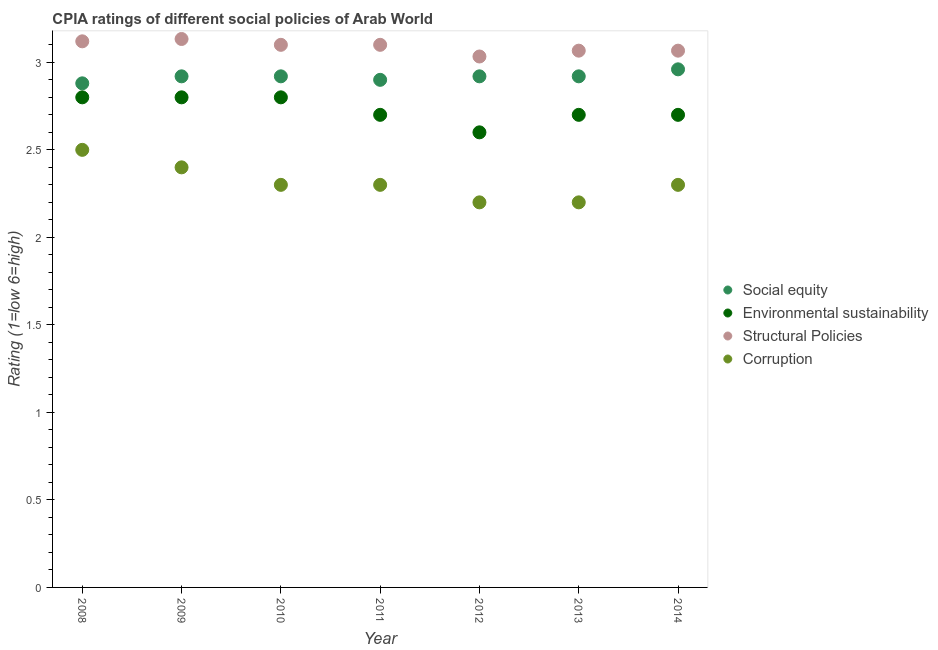Is the number of dotlines equal to the number of legend labels?
Provide a short and direct response. Yes. What is the cpia rating of social equity in 2008?
Offer a terse response. 2.88. Across all years, what is the maximum cpia rating of structural policies?
Ensure brevity in your answer.  3.13. Across all years, what is the minimum cpia rating of social equity?
Keep it short and to the point. 2.88. In which year was the cpia rating of structural policies maximum?
Ensure brevity in your answer.  2009. In which year was the cpia rating of corruption minimum?
Provide a succinct answer. 2012. What is the total cpia rating of social equity in the graph?
Ensure brevity in your answer.  20.42. What is the difference between the cpia rating of environmental sustainability in 2012 and that in 2013?
Keep it short and to the point. -0.1. What is the difference between the cpia rating of corruption in 2008 and the cpia rating of social equity in 2009?
Ensure brevity in your answer.  -0.42. What is the average cpia rating of environmental sustainability per year?
Make the answer very short. 2.73. In the year 2013, what is the difference between the cpia rating of corruption and cpia rating of structural policies?
Make the answer very short. -0.87. What is the ratio of the cpia rating of environmental sustainability in 2009 to that in 2012?
Provide a short and direct response. 1.08. What is the difference between the highest and the second highest cpia rating of social equity?
Your answer should be compact. 0.04. What is the difference between the highest and the lowest cpia rating of structural policies?
Make the answer very short. 0.1. Is the sum of the cpia rating of structural policies in 2010 and 2013 greater than the maximum cpia rating of environmental sustainability across all years?
Offer a terse response. Yes. Is it the case that in every year, the sum of the cpia rating of environmental sustainability and cpia rating of social equity is greater than the sum of cpia rating of structural policies and cpia rating of corruption?
Keep it short and to the point. Yes. Is it the case that in every year, the sum of the cpia rating of social equity and cpia rating of environmental sustainability is greater than the cpia rating of structural policies?
Give a very brief answer. Yes. Does the cpia rating of corruption monotonically increase over the years?
Offer a terse response. No. How many dotlines are there?
Provide a succinct answer. 4. How many years are there in the graph?
Provide a succinct answer. 7. What is the difference between two consecutive major ticks on the Y-axis?
Offer a terse response. 0.5. Does the graph contain any zero values?
Provide a succinct answer. No. How are the legend labels stacked?
Ensure brevity in your answer.  Vertical. What is the title of the graph?
Offer a very short reply. CPIA ratings of different social policies of Arab World. What is the Rating (1=low 6=high) of Social equity in 2008?
Offer a very short reply. 2.88. What is the Rating (1=low 6=high) in Environmental sustainability in 2008?
Your response must be concise. 2.8. What is the Rating (1=low 6=high) of Structural Policies in 2008?
Provide a short and direct response. 3.12. What is the Rating (1=low 6=high) of Social equity in 2009?
Give a very brief answer. 2.92. What is the Rating (1=low 6=high) in Structural Policies in 2009?
Provide a short and direct response. 3.13. What is the Rating (1=low 6=high) of Corruption in 2009?
Keep it short and to the point. 2.4. What is the Rating (1=low 6=high) in Social equity in 2010?
Provide a short and direct response. 2.92. What is the Rating (1=low 6=high) of Structural Policies in 2010?
Ensure brevity in your answer.  3.1. What is the Rating (1=low 6=high) in Social equity in 2011?
Keep it short and to the point. 2.9. What is the Rating (1=low 6=high) of Environmental sustainability in 2011?
Offer a terse response. 2.7. What is the Rating (1=low 6=high) of Structural Policies in 2011?
Make the answer very short. 3.1. What is the Rating (1=low 6=high) of Social equity in 2012?
Make the answer very short. 2.92. What is the Rating (1=low 6=high) of Structural Policies in 2012?
Offer a terse response. 3.03. What is the Rating (1=low 6=high) of Social equity in 2013?
Ensure brevity in your answer.  2.92. What is the Rating (1=low 6=high) in Structural Policies in 2013?
Make the answer very short. 3.07. What is the Rating (1=low 6=high) of Corruption in 2013?
Give a very brief answer. 2.2. What is the Rating (1=low 6=high) in Social equity in 2014?
Make the answer very short. 2.96. What is the Rating (1=low 6=high) in Environmental sustainability in 2014?
Provide a succinct answer. 2.7. What is the Rating (1=low 6=high) of Structural Policies in 2014?
Keep it short and to the point. 3.07. What is the Rating (1=low 6=high) of Corruption in 2014?
Make the answer very short. 2.3. Across all years, what is the maximum Rating (1=low 6=high) of Social equity?
Your answer should be compact. 2.96. Across all years, what is the maximum Rating (1=low 6=high) of Environmental sustainability?
Give a very brief answer. 2.8. Across all years, what is the maximum Rating (1=low 6=high) in Structural Policies?
Make the answer very short. 3.13. Across all years, what is the maximum Rating (1=low 6=high) in Corruption?
Your answer should be compact. 2.5. Across all years, what is the minimum Rating (1=low 6=high) in Social equity?
Provide a short and direct response. 2.88. Across all years, what is the minimum Rating (1=low 6=high) in Structural Policies?
Provide a succinct answer. 3.03. What is the total Rating (1=low 6=high) in Social equity in the graph?
Offer a very short reply. 20.42. What is the total Rating (1=low 6=high) of Environmental sustainability in the graph?
Give a very brief answer. 19.1. What is the total Rating (1=low 6=high) of Structural Policies in the graph?
Offer a terse response. 21.62. What is the difference between the Rating (1=low 6=high) of Social equity in 2008 and that in 2009?
Give a very brief answer. -0.04. What is the difference between the Rating (1=low 6=high) of Environmental sustainability in 2008 and that in 2009?
Offer a very short reply. 0. What is the difference between the Rating (1=low 6=high) in Structural Policies in 2008 and that in 2009?
Your answer should be very brief. -0.01. What is the difference between the Rating (1=low 6=high) of Social equity in 2008 and that in 2010?
Your response must be concise. -0.04. What is the difference between the Rating (1=low 6=high) of Structural Policies in 2008 and that in 2010?
Offer a terse response. 0.02. What is the difference between the Rating (1=low 6=high) of Corruption in 2008 and that in 2010?
Provide a succinct answer. 0.2. What is the difference between the Rating (1=low 6=high) in Social equity in 2008 and that in 2011?
Provide a short and direct response. -0.02. What is the difference between the Rating (1=low 6=high) in Environmental sustainability in 2008 and that in 2011?
Give a very brief answer. 0.1. What is the difference between the Rating (1=low 6=high) in Social equity in 2008 and that in 2012?
Offer a terse response. -0.04. What is the difference between the Rating (1=low 6=high) in Environmental sustainability in 2008 and that in 2012?
Your response must be concise. 0.2. What is the difference between the Rating (1=low 6=high) in Structural Policies in 2008 and that in 2012?
Ensure brevity in your answer.  0.09. What is the difference between the Rating (1=low 6=high) of Corruption in 2008 and that in 2012?
Offer a terse response. 0.3. What is the difference between the Rating (1=low 6=high) of Social equity in 2008 and that in 2013?
Ensure brevity in your answer.  -0.04. What is the difference between the Rating (1=low 6=high) in Structural Policies in 2008 and that in 2013?
Ensure brevity in your answer.  0.05. What is the difference between the Rating (1=low 6=high) in Social equity in 2008 and that in 2014?
Keep it short and to the point. -0.08. What is the difference between the Rating (1=low 6=high) in Structural Policies in 2008 and that in 2014?
Your answer should be compact. 0.05. What is the difference between the Rating (1=low 6=high) of Corruption in 2008 and that in 2014?
Your answer should be very brief. 0.2. What is the difference between the Rating (1=low 6=high) in Environmental sustainability in 2009 and that in 2010?
Provide a short and direct response. 0. What is the difference between the Rating (1=low 6=high) in Social equity in 2009 and that in 2011?
Your answer should be compact. 0.02. What is the difference between the Rating (1=low 6=high) in Environmental sustainability in 2009 and that in 2011?
Your answer should be very brief. 0.1. What is the difference between the Rating (1=low 6=high) of Corruption in 2009 and that in 2011?
Your response must be concise. 0.1. What is the difference between the Rating (1=low 6=high) in Environmental sustainability in 2009 and that in 2012?
Give a very brief answer. 0.2. What is the difference between the Rating (1=low 6=high) in Structural Policies in 2009 and that in 2012?
Offer a terse response. 0.1. What is the difference between the Rating (1=low 6=high) of Corruption in 2009 and that in 2012?
Offer a very short reply. 0.2. What is the difference between the Rating (1=low 6=high) of Environmental sustainability in 2009 and that in 2013?
Your answer should be very brief. 0.1. What is the difference between the Rating (1=low 6=high) in Structural Policies in 2009 and that in 2013?
Your answer should be compact. 0.07. What is the difference between the Rating (1=low 6=high) in Corruption in 2009 and that in 2013?
Your answer should be compact. 0.2. What is the difference between the Rating (1=low 6=high) of Social equity in 2009 and that in 2014?
Offer a very short reply. -0.04. What is the difference between the Rating (1=low 6=high) in Structural Policies in 2009 and that in 2014?
Make the answer very short. 0.07. What is the difference between the Rating (1=low 6=high) of Corruption in 2009 and that in 2014?
Provide a succinct answer. 0.1. What is the difference between the Rating (1=low 6=high) of Social equity in 2010 and that in 2011?
Your response must be concise. 0.02. What is the difference between the Rating (1=low 6=high) of Social equity in 2010 and that in 2012?
Offer a terse response. 0. What is the difference between the Rating (1=low 6=high) in Structural Policies in 2010 and that in 2012?
Offer a terse response. 0.07. What is the difference between the Rating (1=low 6=high) of Corruption in 2010 and that in 2012?
Offer a very short reply. 0.1. What is the difference between the Rating (1=low 6=high) of Social equity in 2010 and that in 2013?
Ensure brevity in your answer.  0. What is the difference between the Rating (1=low 6=high) in Structural Policies in 2010 and that in 2013?
Keep it short and to the point. 0.03. What is the difference between the Rating (1=low 6=high) in Corruption in 2010 and that in 2013?
Offer a terse response. 0.1. What is the difference between the Rating (1=low 6=high) in Social equity in 2010 and that in 2014?
Offer a terse response. -0.04. What is the difference between the Rating (1=low 6=high) of Social equity in 2011 and that in 2012?
Provide a succinct answer. -0.02. What is the difference between the Rating (1=low 6=high) of Environmental sustainability in 2011 and that in 2012?
Keep it short and to the point. 0.1. What is the difference between the Rating (1=low 6=high) of Structural Policies in 2011 and that in 2012?
Offer a very short reply. 0.07. What is the difference between the Rating (1=low 6=high) in Social equity in 2011 and that in 2013?
Your answer should be compact. -0.02. What is the difference between the Rating (1=low 6=high) of Structural Policies in 2011 and that in 2013?
Your answer should be compact. 0.03. What is the difference between the Rating (1=low 6=high) of Corruption in 2011 and that in 2013?
Your answer should be very brief. 0.1. What is the difference between the Rating (1=low 6=high) of Social equity in 2011 and that in 2014?
Make the answer very short. -0.06. What is the difference between the Rating (1=low 6=high) in Social equity in 2012 and that in 2013?
Your answer should be very brief. 0. What is the difference between the Rating (1=low 6=high) in Environmental sustainability in 2012 and that in 2013?
Ensure brevity in your answer.  -0.1. What is the difference between the Rating (1=low 6=high) of Structural Policies in 2012 and that in 2013?
Give a very brief answer. -0.03. What is the difference between the Rating (1=low 6=high) of Social equity in 2012 and that in 2014?
Keep it short and to the point. -0.04. What is the difference between the Rating (1=low 6=high) of Structural Policies in 2012 and that in 2014?
Your answer should be compact. -0.03. What is the difference between the Rating (1=low 6=high) of Social equity in 2013 and that in 2014?
Your answer should be very brief. -0.04. What is the difference between the Rating (1=low 6=high) of Structural Policies in 2013 and that in 2014?
Provide a succinct answer. -0. What is the difference between the Rating (1=low 6=high) in Corruption in 2013 and that in 2014?
Make the answer very short. -0.1. What is the difference between the Rating (1=low 6=high) of Social equity in 2008 and the Rating (1=low 6=high) of Structural Policies in 2009?
Offer a very short reply. -0.25. What is the difference between the Rating (1=low 6=high) in Social equity in 2008 and the Rating (1=low 6=high) in Corruption in 2009?
Make the answer very short. 0.48. What is the difference between the Rating (1=low 6=high) of Environmental sustainability in 2008 and the Rating (1=low 6=high) of Structural Policies in 2009?
Give a very brief answer. -0.33. What is the difference between the Rating (1=low 6=high) of Environmental sustainability in 2008 and the Rating (1=low 6=high) of Corruption in 2009?
Your answer should be compact. 0.4. What is the difference between the Rating (1=low 6=high) in Structural Policies in 2008 and the Rating (1=low 6=high) in Corruption in 2009?
Offer a very short reply. 0.72. What is the difference between the Rating (1=low 6=high) of Social equity in 2008 and the Rating (1=low 6=high) of Structural Policies in 2010?
Make the answer very short. -0.22. What is the difference between the Rating (1=low 6=high) in Social equity in 2008 and the Rating (1=low 6=high) in Corruption in 2010?
Provide a short and direct response. 0.58. What is the difference between the Rating (1=low 6=high) in Environmental sustainability in 2008 and the Rating (1=low 6=high) in Structural Policies in 2010?
Your response must be concise. -0.3. What is the difference between the Rating (1=low 6=high) in Structural Policies in 2008 and the Rating (1=low 6=high) in Corruption in 2010?
Offer a terse response. 0.82. What is the difference between the Rating (1=low 6=high) of Social equity in 2008 and the Rating (1=low 6=high) of Environmental sustainability in 2011?
Keep it short and to the point. 0.18. What is the difference between the Rating (1=low 6=high) in Social equity in 2008 and the Rating (1=low 6=high) in Structural Policies in 2011?
Your answer should be very brief. -0.22. What is the difference between the Rating (1=low 6=high) of Social equity in 2008 and the Rating (1=low 6=high) of Corruption in 2011?
Your answer should be compact. 0.58. What is the difference between the Rating (1=low 6=high) in Structural Policies in 2008 and the Rating (1=low 6=high) in Corruption in 2011?
Provide a succinct answer. 0.82. What is the difference between the Rating (1=low 6=high) in Social equity in 2008 and the Rating (1=low 6=high) in Environmental sustainability in 2012?
Ensure brevity in your answer.  0.28. What is the difference between the Rating (1=low 6=high) in Social equity in 2008 and the Rating (1=low 6=high) in Structural Policies in 2012?
Your answer should be compact. -0.15. What is the difference between the Rating (1=low 6=high) of Social equity in 2008 and the Rating (1=low 6=high) of Corruption in 2012?
Give a very brief answer. 0.68. What is the difference between the Rating (1=low 6=high) in Environmental sustainability in 2008 and the Rating (1=low 6=high) in Structural Policies in 2012?
Your answer should be compact. -0.23. What is the difference between the Rating (1=low 6=high) of Environmental sustainability in 2008 and the Rating (1=low 6=high) of Corruption in 2012?
Provide a short and direct response. 0.6. What is the difference between the Rating (1=low 6=high) of Social equity in 2008 and the Rating (1=low 6=high) of Environmental sustainability in 2013?
Ensure brevity in your answer.  0.18. What is the difference between the Rating (1=low 6=high) in Social equity in 2008 and the Rating (1=low 6=high) in Structural Policies in 2013?
Offer a terse response. -0.19. What is the difference between the Rating (1=low 6=high) of Social equity in 2008 and the Rating (1=low 6=high) of Corruption in 2013?
Your response must be concise. 0.68. What is the difference between the Rating (1=low 6=high) of Environmental sustainability in 2008 and the Rating (1=low 6=high) of Structural Policies in 2013?
Your response must be concise. -0.27. What is the difference between the Rating (1=low 6=high) of Environmental sustainability in 2008 and the Rating (1=low 6=high) of Corruption in 2013?
Ensure brevity in your answer.  0.6. What is the difference between the Rating (1=low 6=high) in Structural Policies in 2008 and the Rating (1=low 6=high) in Corruption in 2013?
Provide a short and direct response. 0.92. What is the difference between the Rating (1=low 6=high) of Social equity in 2008 and the Rating (1=low 6=high) of Environmental sustainability in 2014?
Your answer should be compact. 0.18. What is the difference between the Rating (1=low 6=high) of Social equity in 2008 and the Rating (1=low 6=high) of Structural Policies in 2014?
Offer a terse response. -0.19. What is the difference between the Rating (1=low 6=high) of Social equity in 2008 and the Rating (1=low 6=high) of Corruption in 2014?
Give a very brief answer. 0.58. What is the difference between the Rating (1=low 6=high) of Environmental sustainability in 2008 and the Rating (1=low 6=high) of Structural Policies in 2014?
Offer a very short reply. -0.27. What is the difference between the Rating (1=low 6=high) of Environmental sustainability in 2008 and the Rating (1=low 6=high) of Corruption in 2014?
Provide a short and direct response. 0.5. What is the difference between the Rating (1=low 6=high) in Structural Policies in 2008 and the Rating (1=low 6=high) in Corruption in 2014?
Your answer should be compact. 0.82. What is the difference between the Rating (1=low 6=high) in Social equity in 2009 and the Rating (1=low 6=high) in Environmental sustainability in 2010?
Offer a very short reply. 0.12. What is the difference between the Rating (1=low 6=high) of Social equity in 2009 and the Rating (1=low 6=high) of Structural Policies in 2010?
Offer a very short reply. -0.18. What is the difference between the Rating (1=low 6=high) of Social equity in 2009 and the Rating (1=low 6=high) of Corruption in 2010?
Provide a succinct answer. 0.62. What is the difference between the Rating (1=low 6=high) of Environmental sustainability in 2009 and the Rating (1=low 6=high) of Structural Policies in 2010?
Provide a succinct answer. -0.3. What is the difference between the Rating (1=low 6=high) of Social equity in 2009 and the Rating (1=low 6=high) of Environmental sustainability in 2011?
Offer a terse response. 0.22. What is the difference between the Rating (1=low 6=high) of Social equity in 2009 and the Rating (1=low 6=high) of Structural Policies in 2011?
Make the answer very short. -0.18. What is the difference between the Rating (1=low 6=high) in Social equity in 2009 and the Rating (1=low 6=high) in Corruption in 2011?
Provide a succinct answer. 0.62. What is the difference between the Rating (1=low 6=high) of Environmental sustainability in 2009 and the Rating (1=low 6=high) of Structural Policies in 2011?
Offer a terse response. -0.3. What is the difference between the Rating (1=low 6=high) in Structural Policies in 2009 and the Rating (1=low 6=high) in Corruption in 2011?
Make the answer very short. 0.83. What is the difference between the Rating (1=low 6=high) in Social equity in 2009 and the Rating (1=low 6=high) in Environmental sustainability in 2012?
Your answer should be very brief. 0.32. What is the difference between the Rating (1=low 6=high) in Social equity in 2009 and the Rating (1=low 6=high) in Structural Policies in 2012?
Your answer should be very brief. -0.11. What is the difference between the Rating (1=low 6=high) of Social equity in 2009 and the Rating (1=low 6=high) of Corruption in 2012?
Offer a terse response. 0.72. What is the difference between the Rating (1=low 6=high) of Environmental sustainability in 2009 and the Rating (1=low 6=high) of Structural Policies in 2012?
Provide a succinct answer. -0.23. What is the difference between the Rating (1=low 6=high) of Social equity in 2009 and the Rating (1=low 6=high) of Environmental sustainability in 2013?
Provide a short and direct response. 0.22. What is the difference between the Rating (1=low 6=high) of Social equity in 2009 and the Rating (1=low 6=high) of Structural Policies in 2013?
Your response must be concise. -0.15. What is the difference between the Rating (1=low 6=high) of Social equity in 2009 and the Rating (1=low 6=high) of Corruption in 2013?
Provide a short and direct response. 0.72. What is the difference between the Rating (1=low 6=high) in Environmental sustainability in 2009 and the Rating (1=low 6=high) in Structural Policies in 2013?
Offer a terse response. -0.27. What is the difference between the Rating (1=low 6=high) of Environmental sustainability in 2009 and the Rating (1=low 6=high) of Corruption in 2013?
Give a very brief answer. 0.6. What is the difference between the Rating (1=low 6=high) of Social equity in 2009 and the Rating (1=low 6=high) of Environmental sustainability in 2014?
Offer a very short reply. 0.22. What is the difference between the Rating (1=low 6=high) of Social equity in 2009 and the Rating (1=low 6=high) of Structural Policies in 2014?
Offer a very short reply. -0.15. What is the difference between the Rating (1=low 6=high) in Social equity in 2009 and the Rating (1=low 6=high) in Corruption in 2014?
Your answer should be compact. 0.62. What is the difference between the Rating (1=low 6=high) of Environmental sustainability in 2009 and the Rating (1=low 6=high) of Structural Policies in 2014?
Provide a short and direct response. -0.27. What is the difference between the Rating (1=low 6=high) in Environmental sustainability in 2009 and the Rating (1=low 6=high) in Corruption in 2014?
Give a very brief answer. 0.5. What is the difference between the Rating (1=low 6=high) in Social equity in 2010 and the Rating (1=low 6=high) in Environmental sustainability in 2011?
Your answer should be very brief. 0.22. What is the difference between the Rating (1=low 6=high) in Social equity in 2010 and the Rating (1=low 6=high) in Structural Policies in 2011?
Keep it short and to the point. -0.18. What is the difference between the Rating (1=low 6=high) in Social equity in 2010 and the Rating (1=low 6=high) in Corruption in 2011?
Ensure brevity in your answer.  0.62. What is the difference between the Rating (1=low 6=high) in Environmental sustainability in 2010 and the Rating (1=low 6=high) in Structural Policies in 2011?
Your response must be concise. -0.3. What is the difference between the Rating (1=low 6=high) of Structural Policies in 2010 and the Rating (1=low 6=high) of Corruption in 2011?
Offer a very short reply. 0.8. What is the difference between the Rating (1=low 6=high) in Social equity in 2010 and the Rating (1=low 6=high) in Environmental sustainability in 2012?
Give a very brief answer. 0.32. What is the difference between the Rating (1=low 6=high) of Social equity in 2010 and the Rating (1=low 6=high) of Structural Policies in 2012?
Ensure brevity in your answer.  -0.11. What is the difference between the Rating (1=low 6=high) in Social equity in 2010 and the Rating (1=low 6=high) in Corruption in 2012?
Keep it short and to the point. 0.72. What is the difference between the Rating (1=low 6=high) in Environmental sustainability in 2010 and the Rating (1=low 6=high) in Structural Policies in 2012?
Give a very brief answer. -0.23. What is the difference between the Rating (1=low 6=high) of Structural Policies in 2010 and the Rating (1=low 6=high) of Corruption in 2012?
Your answer should be compact. 0.9. What is the difference between the Rating (1=low 6=high) in Social equity in 2010 and the Rating (1=low 6=high) in Environmental sustainability in 2013?
Your response must be concise. 0.22. What is the difference between the Rating (1=low 6=high) of Social equity in 2010 and the Rating (1=low 6=high) of Structural Policies in 2013?
Ensure brevity in your answer.  -0.15. What is the difference between the Rating (1=low 6=high) in Social equity in 2010 and the Rating (1=low 6=high) in Corruption in 2013?
Give a very brief answer. 0.72. What is the difference between the Rating (1=low 6=high) of Environmental sustainability in 2010 and the Rating (1=low 6=high) of Structural Policies in 2013?
Your response must be concise. -0.27. What is the difference between the Rating (1=low 6=high) of Social equity in 2010 and the Rating (1=low 6=high) of Environmental sustainability in 2014?
Provide a succinct answer. 0.22. What is the difference between the Rating (1=low 6=high) in Social equity in 2010 and the Rating (1=low 6=high) in Structural Policies in 2014?
Make the answer very short. -0.15. What is the difference between the Rating (1=low 6=high) in Social equity in 2010 and the Rating (1=low 6=high) in Corruption in 2014?
Your response must be concise. 0.62. What is the difference between the Rating (1=low 6=high) of Environmental sustainability in 2010 and the Rating (1=low 6=high) of Structural Policies in 2014?
Offer a very short reply. -0.27. What is the difference between the Rating (1=low 6=high) in Environmental sustainability in 2010 and the Rating (1=low 6=high) in Corruption in 2014?
Your response must be concise. 0.5. What is the difference between the Rating (1=low 6=high) in Social equity in 2011 and the Rating (1=low 6=high) in Structural Policies in 2012?
Your answer should be compact. -0.13. What is the difference between the Rating (1=low 6=high) in Environmental sustainability in 2011 and the Rating (1=low 6=high) in Structural Policies in 2012?
Keep it short and to the point. -0.33. What is the difference between the Rating (1=low 6=high) in Structural Policies in 2011 and the Rating (1=low 6=high) in Corruption in 2012?
Your answer should be compact. 0.9. What is the difference between the Rating (1=low 6=high) of Social equity in 2011 and the Rating (1=low 6=high) of Structural Policies in 2013?
Provide a succinct answer. -0.17. What is the difference between the Rating (1=low 6=high) in Social equity in 2011 and the Rating (1=low 6=high) in Corruption in 2013?
Provide a succinct answer. 0.7. What is the difference between the Rating (1=low 6=high) in Environmental sustainability in 2011 and the Rating (1=low 6=high) in Structural Policies in 2013?
Keep it short and to the point. -0.37. What is the difference between the Rating (1=low 6=high) in Structural Policies in 2011 and the Rating (1=low 6=high) in Corruption in 2013?
Keep it short and to the point. 0.9. What is the difference between the Rating (1=low 6=high) in Social equity in 2011 and the Rating (1=low 6=high) in Structural Policies in 2014?
Ensure brevity in your answer.  -0.17. What is the difference between the Rating (1=low 6=high) in Environmental sustainability in 2011 and the Rating (1=low 6=high) in Structural Policies in 2014?
Your response must be concise. -0.37. What is the difference between the Rating (1=low 6=high) of Environmental sustainability in 2011 and the Rating (1=low 6=high) of Corruption in 2014?
Your response must be concise. 0.4. What is the difference between the Rating (1=low 6=high) in Structural Policies in 2011 and the Rating (1=low 6=high) in Corruption in 2014?
Keep it short and to the point. 0.8. What is the difference between the Rating (1=low 6=high) in Social equity in 2012 and the Rating (1=low 6=high) in Environmental sustainability in 2013?
Make the answer very short. 0.22. What is the difference between the Rating (1=low 6=high) in Social equity in 2012 and the Rating (1=low 6=high) in Structural Policies in 2013?
Give a very brief answer. -0.15. What is the difference between the Rating (1=low 6=high) in Social equity in 2012 and the Rating (1=low 6=high) in Corruption in 2013?
Make the answer very short. 0.72. What is the difference between the Rating (1=low 6=high) in Environmental sustainability in 2012 and the Rating (1=low 6=high) in Structural Policies in 2013?
Your answer should be very brief. -0.47. What is the difference between the Rating (1=low 6=high) in Environmental sustainability in 2012 and the Rating (1=low 6=high) in Corruption in 2013?
Make the answer very short. 0.4. What is the difference between the Rating (1=low 6=high) in Structural Policies in 2012 and the Rating (1=low 6=high) in Corruption in 2013?
Offer a terse response. 0.83. What is the difference between the Rating (1=low 6=high) of Social equity in 2012 and the Rating (1=low 6=high) of Environmental sustainability in 2014?
Provide a short and direct response. 0.22. What is the difference between the Rating (1=low 6=high) of Social equity in 2012 and the Rating (1=low 6=high) of Structural Policies in 2014?
Keep it short and to the point. -0.15. What is the difference between the Rating (1=low 6=high) in Social equity in 2012 and the Rating (1=low 6=high) in Corruption in 2014?
Make the answer very short. 0.62. What is the difference between the Rating (1=low 6=high) of Environmental sustainability in 2012 and the Rating (1=low 6=high) of Structural Policies in 2014?
Provide a short and direct response. -0.47. What is the difference between the Rating (1=low 6=high) of Structural Policies in 2012 and the Rating (1=low 6=high) of Corruption in 2014?
Give a very brief answer. 0.73. What is the difference between the Rating (1=low 6=high) in Social equity in 2013 and the Rating (1=low 6=high) in Environmental sustainability in 2014?
Keep it short and to the point. 0.22. What is the difference between the Rating (1=low 6=high) in Social equity in 2013 and the Rating (1=low 6=high) in Structural Policies in 2014?
Offer a very short reply. -0.15. What is the difference between the Rating (1=low 6=high) of Social equity in 2013 and the Rating (1=low 6=high) of Corruption in 2014?
Give a very brief answer. 0.62. What is the difference between the Rating (1=low 6=high) of Environmental sustainability in 2013 and the Rating (1=low 6=high) of Structural Policies in 2014?
Offer a very short reply. -0.37. What is the difference between the Rating (1=low 6=high) of Environmental sustainability in 2013 and the Rating (1=low 6=high) of Corruption in 2014?
Your answer should be compact. 0.4. What is the difference between the Rating (1=low 6=high) of Structural Policies in 2013 and the Rating (1=low 6=high) of Corruption in 2014?
Offer a terse response. 0.77. What is the average Rating (1=low 6=high) of Social equity per year?
Provide a succinct answer. 2.92. What is the average Rating (1=low 6=high) of Environmental sustainability per year?
Ensure brevity in your answer.  2.73. What is the average Rating (1=low 6=high) of Structural Policies per year?
Make the answer very short. 3.09. What is the average Rating (1=low 6=high) of Corruption per year?
Offer a terse response. 2.31. In the year 2008, what is the difference between the Rating (1=low 6=high) in Social equity and Rating (1=low 6=high) in Structural Policies?
Keep it short and to the point. -0.24. In the year 2008, what is the difference between the Rating (1=low 6=high) in Social equity and Rating (1=low 6=high) in Corruption?
Provide a short and direct response. 0.38. In the year 2008, what is the difference between the Rating (1=low 6=high) of Environmental sustainability and Rating (1=low 6=high) of Structural Policies?
Your answer should be very brief. -0.32. In the year 2008, what is the difference between the Rating (1=low 6=high) of Structural Policies and Rating (1=low 6=high) of Corruption?
Your answer should be compact. 0.62. In the year 2009, what is the difference between the Rating (1=low 6=high) of Social equity and Rating (1=low 6=high) of Environmental sustainability?
Your response must be concise. 0.12. In the year 2009, what is the difference between the Rating (1=low 6=high) in Social equity and Rating (1=low 6=high) in Structural Policies?
Your response must be concise. -0.21. In the year 2009, what is the difference between the Rating (1=low 6=high) in Social equity and Rating (1=low 6=high) in Corruption?
Offer a terse response. 0.52. In the year 2009, what is the difference between the Rating (1=low 6=high) of Structural Policies and Rating (1=low 6=high) of Corruption?
Your answer should be compact. 0.73. In the year 2010, what is the difference between the Rating (1=low 6=high) of Social equity and Rating (1=low 6=high) of Environmental sustainability?
Ensure brevity in your answer.  0.12. In the year 2010, what is the difference between the Rating (1=low 6=high) of Social equity and Rating (1=low 6=high) of Structural Policies?
Provide a succinct answer. -0.18. In the year 2010, what is the difference between the Rating (1=low 6=high) in Social equity and Rating (1=low 6=high) in Corruption?
Offer a terse response. 0.62. In the year 2010, what is the difference between the Rating (1=low 6=high) in Environmental sustainability and Rating (1=low 6=high) in Structural Policies?
Offer a very short reply. -0.3. In the year 2010, what is the difference between the Rating (1=low 6=high) in Structural Policies and Rating (1=low 6=high) in Corruption?
Provide a short and direct response. 0.8. In the year 2011, what is the difference between the Rating (1=low 6=high) of Social equity and Rating (1=low 6=high) of Environmental sustainability?
Ensure brevity in your answer.  0.2. In the year 2011, what is the difference between the Rating (1=low 6=high) of Social equity and Rating (1=low 6=high) of Structural Policies?
Your answer should be very brief. -0.2. In the year 2011, what is the difference between the Rating (1=low 6=high) in Social equity and Rating (1=low 6=high) in Corruption?
Offer a very short reply. 0.6. In the year 2011, what is the difference between the Rating (1=low 6=high) in Environmental sustainability and Rating (1=low 6=high) in Structural Policies?
Keep it short and to the point. -0.4. In the year 2011, what is the difference between the Rating (1=low 6=high) in Environmental sustainability and Rating (1=low 6=high) in Corruption?
Provide a succinct answer. 0.4. In the year 2011, what is the difference between the Rating (1=low 6=high) of Structural Policies and Rating (1=low 6=high) of Corruption?
Make the answer very short. 0.8. In the year 2012, what is the difference between the Rating (1=low 6=high) in Social equity and Rating (1=low 6=high) in Environmental sustainability?
Your answer should be compact. 0.32. In the year 2012, what is the difference between the Rating (1=low 6=high) of Social equity and Rating (1=low 6=high) of Structural Policies?
Offer a very short reply. -0.11. In the year 2012, what is the difference between the Rating (1=low 6=high) in Social equity and Rating (1=low 6=high) in Corruption?
Offer a very short reply. 0.72. In the year 2012, what is the difference between the Rating (1=low 6=high) of Environmental sustainability and Rating (1=low 6=high) of Structural Policies?
Give a very brief answer. -0.43. In the year 2012, what is the difference between the Rating (1=low 6=high) of Environmental sustainability and Rating (1=low 6=high) of Corruption?
Your response must be concise. 0.4. In the year 2013, what is the difference between the Rating (1=low 6=high) of Social equity and Rating (1=low 6=high) of Environmental sustainability?
Provide a succinct answer. 0.22. In the year 2013, what is the difference between the Rating (1=low 6=high) of Social equity and Rating (1=low 6=high) of Structural Policies?
Provide a succinct answer. -0.15. In the year 2013, what is the difference between the Rating (1=low 6=high) in Social equity and Rating (1=low 6=high) in Corruption?
Your answer should be very brief. 0.72. In the year 2013, what is the difference between the Rating (1=low 6=high) of Environmental sustainability and Rating (1=low 6=high) of Structural Policies?
Offer a terse response. -0.37. In the year 2013, what is the difference between the Rating (1=low 6=high) in Environmental sustainability and Rating (1=low 6=high) in Corruption?
Your response must be concise. 0.5. In the year 2013, what is the difference between the Rating (1=low 6=high) in Structural Policies and Rating (1=low 6=high) in Corruption?
Ensure brevity in your answer.  0.87. In the year 2014, what is the difference between the Rating (1=low 6=high) in Social equity and Rating (1=low 6=high) in Environmental sustainability?
Offer a very short reply. 0.26. In the year 2014, what is the difference between the Rating (1=low 6=high) in Social equity and Rating (1=low 6=high) in Structural Policies?
Your response must be concise. -0.11. In the year 2014, what is the difference between the Rating (1=low 6=high) in Social equity and Rating (1=low 6=high) in Corruption?
Offer a terse response. 0.66. In the year 2014, what is the difference between the Rating (1=low 6=high) of Environmental sustainability and Rating (1=low 6=high) of Structural Policies?
Offer a terse response. -0.37. In the year 2014, what is the difference between the Rating (1=low 6=high) in Structural Policies and Rating (1=low 6=high) in Corruption?
Offer a very short reply. 0.77. What is the ratio of the Rating (1=low 6=high) of Social equity in 2008 to that in 2009?
Your answer should be compact. 0.99. What is the ratio of the Rating (1=low 6=high) of Structural Policies in 2008 to that in 2009?
Provide a short and direct response. 1. What is the ratio of the Rating (1=low 6=high) of Corruption in 2008 to that in 2009?
Offer a very short reply. 1.04. What is the ratio of the Rating (1=low 6=high) in Social equity in 2008 to that in 2010?
Give a very brief answer. 0.99. What is the ratio of the Rating (1=low 6=high) of Environmental sustainability in 2008 to that in 2010?
Provide a short and direct response. 1. What is the ratio of the Rating (1=low 6=high) of Corruption in 2008 to that in 2010?
Your answer should be compact. 1.09. What is the ratio of the Rating (1=low 6=high) of Social equity in 2008 to that in 2011?
Your answer should be compact. 0.99. What is the ratio of the Rating (1=low 6=high) of Environmental sustainability in 2008 to that in 2011?
Make the answer very short. 1.04. What is the ratio of the Rating (1=low 6=high) in Corruption in 2008 to that in 2011?
Your response must be concise. 1.09. What is the ratio of the Rating (1=low 6=high) in Social equity in 2008 to that in 2012?
Offer a very short reply. 0.99. What is the ratio of the Rating (1=low 6=high) in Environmental sustainability in 2008 to that in 2012?
Your response must be concise. 1.08. What is the ratio of the Rating (1=low 6=high) in Structural Policies in 2008 to that in 2012?
Provide a short and direct response. 1.03. What is the ratio of the Rating (1=low 6=high) of Corruption in 2008 to that in 2012?
Make the answer very short. 1.14. What is the ratio of the Rating (1=low 6=high) of Social equity in 2008 to that in 2013?
Make the answer very short. 0.99. What is the ratio of the Rating (1=low 6=high) of Structural Policies in 2008 to that in 2013?
Provide a succinct answer. 1.02. What is the ratio of the Rating (1=low 6=high) of Corruption in 2008 to that in 2013?
Provide a short and direct response. 1.14. What is the ratio of the Rating (1=low 6=high) of Social equity in 2008 to that in 2014?
Offer a terse response. 0.97. What is the ratio of the Rating (1=low 6=high) in Structural Policies in 2008 to that in 2014?
Give a very brief answer. 1.02. What is the ratio of the Rating (1=low 6=high) of Corruption in 2008 to that in 2014?
Offer a terse response. 1.09. What is the ratio of the Rating (1=low 6=high) of Social equity in 2009 to that in 2010?
Your response must be concise. 1. What is the ratio of the Rating (1=low 6=high) of Structural Policies in 2009 to that in 2010?
Your response must be concise. 1.01. What is the ratio of the Rating (1=low 6=high) of Corruption in 2009 to that in 2010?
Your answer should be very brief. 1.04. What is the ratio of the Rating (1=low 6=high) in Social equity in 2009 to that in 2011?
Your answer should be very brief. 1.01. What is the ratio of the Rating (1=low 6=high) of Environmental sustainability in 2009 to that in 2011?
Provide a short and direct response. 1.04. What is the ratio of the Rating (1=low 6=high) of Structural Policies in 2009 to that in 2011?
Make the answer very short. 1.01. What is the ratio of the Rating (1=low 6=high) in Corruption in 2009 to that in 2011?
Offer a very short reply. 1.04. What is the ratio of the Rating (1=low 6=high) in Social equity in 2009 to that in 2012?
Keep it short and to the point. 1. What is the ratio of the Rating (1=low 6=high) of Environmental sustainability in 2009 to that in 2012?
Your response must be concise. 1.08. What is the ratio of the Rating (1=low 6=high) of Structural Policies in 2009 to that in 2012?
Your response must be concise. 1.03. What is the ratio of the Rating (1=low 6=high) of Corruption in 2009 to that in 2012?
Provide a short and direct response. 1.09. What is the ratio of the Rating (1=low 6=high) of Social equity in 2009 to that in 2013?
Give a very brief answer. 1. What is the ratio of the Rating (1=low 6=high) in Structural Policies in 2009 to that in 2013?
Give a very brief answer. 1.02. What is the ratio of the Rating (1=low 6=high) in Corruption in 2009 to that in 2013?
Ensure brevity in your answer.  1.09. What is the ratio of the Rating (1=low 6=high) of Social equity in 2009 to that in 2014?
Make the answer very short. 0.99. What is the ratio of the Rating (1=low 6=high) of Environmental sustainability in 2009 to that in 2014?
Keep it short and to the point. 1.04. What is the ratio of the Rating (1=low 6=high) in Structural Policies in 2009 to that in 2014?
Your response must be concise. 1.02. What is the ratio of the Rating (1=low 6=high) in Corruption in 2009 to that in 2014?
Give a very brief answer. 1.04. What is the ratio of the Rating (1=low 6=high) in Social equity in 2010 to that in 2011?
Your answer should be very brief. 1.01. What is the ratio of the Rating (1=low 6=high) in Social equity in 2010 to that in 2012?
Your answer should be compact. 1. What is the ratio of the Rating (1=low 6=high) in Corruption in 2010 to that in 2012?
Make the answer very short. 1.05. What is the ratio of the Rating (1=low 6=high) of Environmental sustainability in 2010 to that in 2013?
Provide a short and direct response. 1.04. What is the ratio of the Rating (1=low 6=high) in Structural Policies in 2010 to that in 2013?
Your answer should be very brief. 1.01. What is the ratio of the Rating (1=low 6=high) in Corruption in 2010 to that in 2013?
Provide a succinct answer. 1.05. What is the ratio of the Rating (1=low 6=high) in Social equity in 2010 to that in 2014?
Your response must be concise. 0.99. What is the ratio of the Rating (1=low 6=high) of Structural Policies in 2010 to that in 2014?
Offer a very short reply. 1.01. What is the ratio of the Rating (1=low 6=high) in Structural Policies in 2011 to that in 2012?
Provide a succinct answer. 1.02. What is the ratio of the Rating (1=low 6=high) of Corruption in 2011 to that in 2012?
Keep it short and to the point. 1.05. What is the ratio of the Rating (1=low 6=high) in Environmental sustainability in 2011 to that in 2013?
Provide a succinct answer. 1. What is the ratio of the Rating (1=low 6=high) in Structural Policies in 2011 to that in 2013?
Ensure brevity in your answer.  1.01. What is the ratio of the Rating (1=low 6=high) in Corruption in 2011 to that in 2013?
Keep it short and to the point. 1.05. What is the ratio of the Rating (1=low 6=high) in Social equity in 2011 to that in 2014?
Your answer should be very brief. 0.98. What is the ratio of the Rating (1=low 6=high) in Environmental sustainability in 2011 to that in 2014?
Your answer should be compact. 1. What is the ratio of the Rating (1=low 6=high) in Structural Policies in 2011 to that in 2014?
Make the answer very short. 1.01. What is the ratio of the Rating (1=low 6=high) in Corruption in 2011 to that in 2014?
Keep it short and to the point. 1. What is the ratio of the Rating (1=low 6=high) of Social equity in 2012 to that in 2013?
Offer a terse response. 1. What is the ratio of the Rating (1=low 6=high) of Social equity in 2012 to that in 2014?
Your answer should be compact. 0.99. What is the ratio of the Rating (1=low 6=high) of Environmental sustainability in 2012 to that in 2014?
Keep it short and to the point. 0.96. What is the ratio of the Rating (1=low 6=high) in Structural Policies in 2012 to that in 2014?
Provide a short and direct response. 0.99. What is the ratio of the Rating (1=low 6=high) of Corruption in 2012 to that in 2014?
Your answer should be very brief. 0.96. What is the ratio of the Rating (1=low 6=high) in Social equity in 2013 to that in 2014?
Keep it short and to the point. 0.99. What is the ratio of the Rating (1=low 6=high) in Corruption in 2013 to that in 2014?
Provide a short and direct response. 0.96. What is the difference between the highest and the second highest Rating (1=low 6=high) of Structural Policies?
Give a very brief answer. 0.01. What is the difference between the highest and the second highest Rating (1=low 6=high) of Corruption?
Make the answer very short. 0.1. What is the difference between the highest and the lowest Rating (1=low 6=high) of Corruption?
Your answer should be compact. 0.3. 